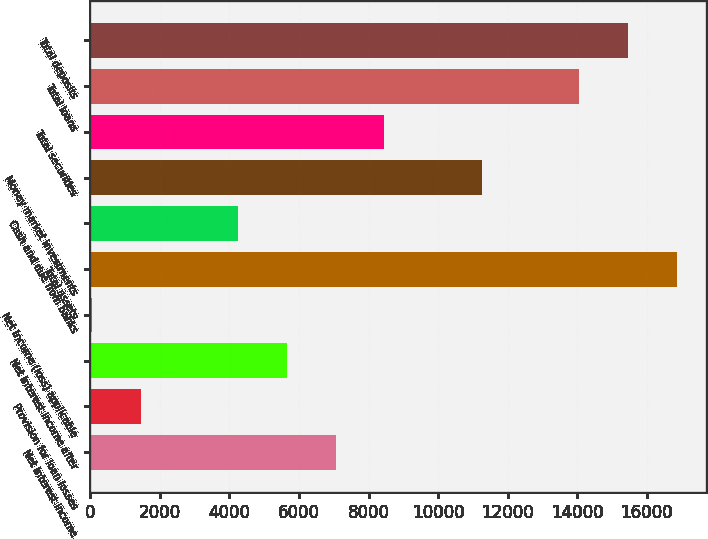Convert chart. <chart><loc_0><loc_0><loc_500><loc_500><bar_chart><fcel>Net interest income<fcel>Provision for loan losses<fcel>Net interest income after<fcel>Net income (loss) applicable<fcel>Total assets<fcel>Cash and due from banks<fcel>Money market investments<fcel>Total securities<fcel>Total loans<fcel>Total deposits<nl><fcel>7053.4<fcel>1446.52<fcel>5651.68<fcel>44.8<fcel>16865.4<fcel>4249.96<fcel>11258.6<fcel>8455.12<fcel>14062<fcel>15463.7<nl></chart> 